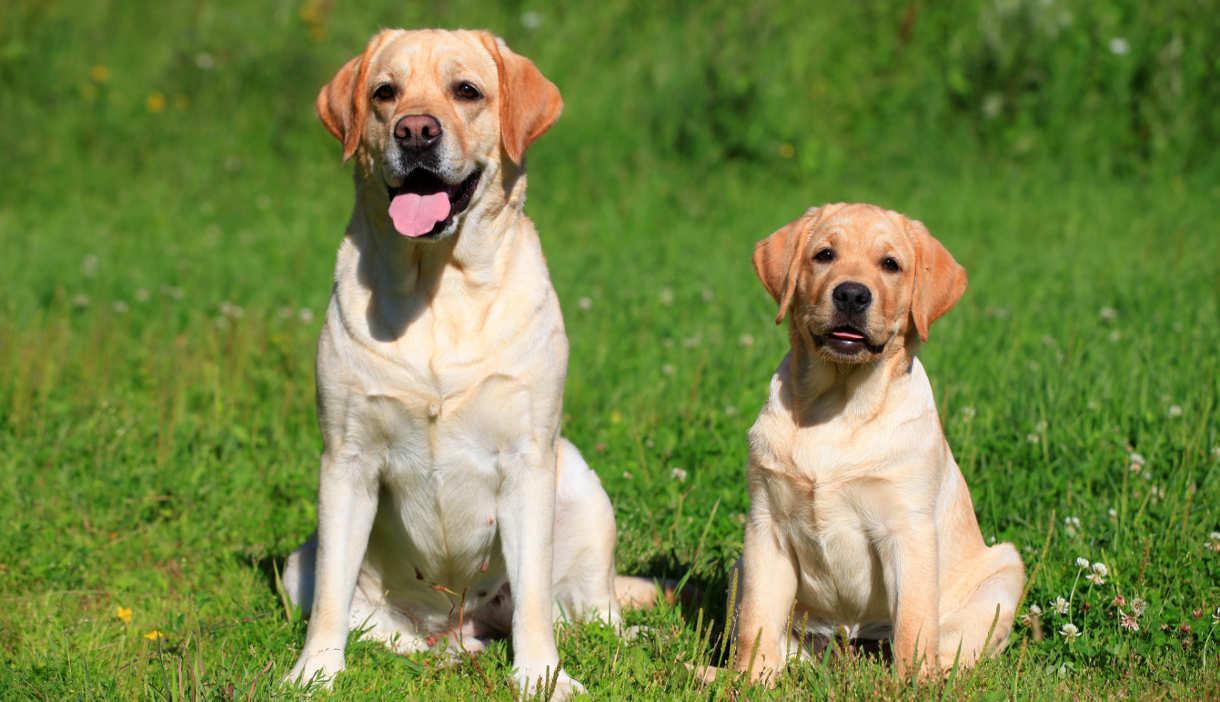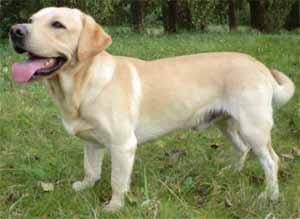The first image is the image on the left, the second image is the image on the right. For the images displayed, is the sentence "The combined images include two standing dogs, with at least one of them wearing a collar but no pack." factually correct? Answer yes or no. No. The first image is the image on the left, the second image is the image on the right. For the images displayed, is the sentence "The left image contains exactly two dogs." factually correct? Answer yes or no. Yes. 